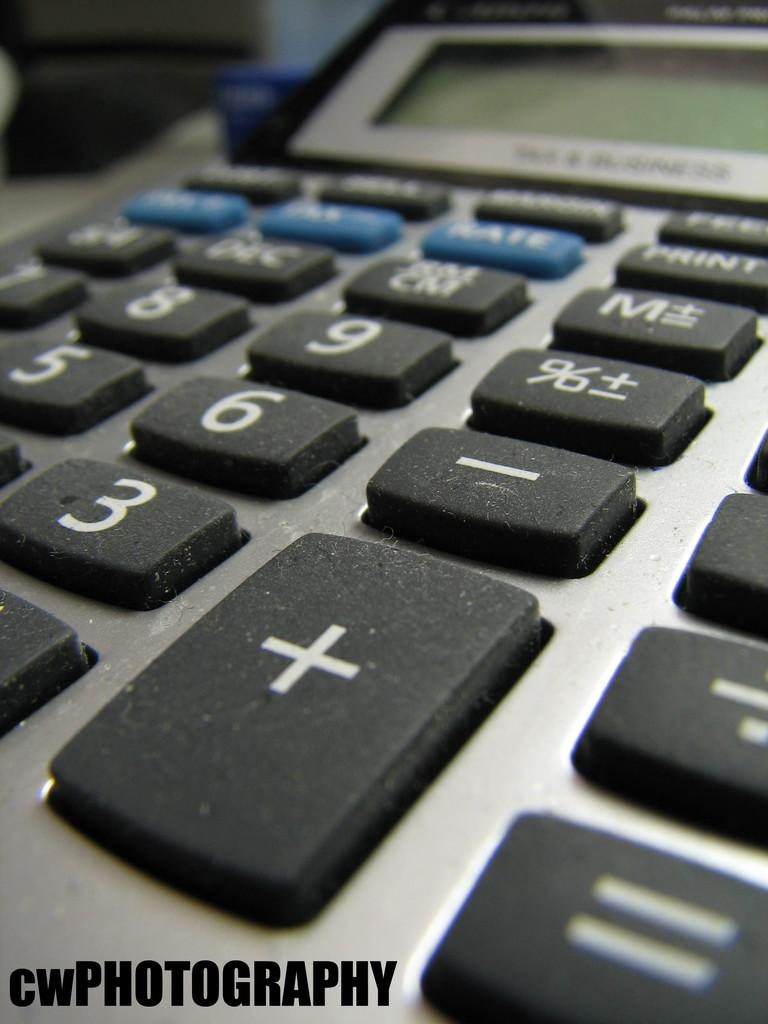<image>
Describe the image concisely. A calculator has blue and black keys and a cwPhotography log in the corner. 